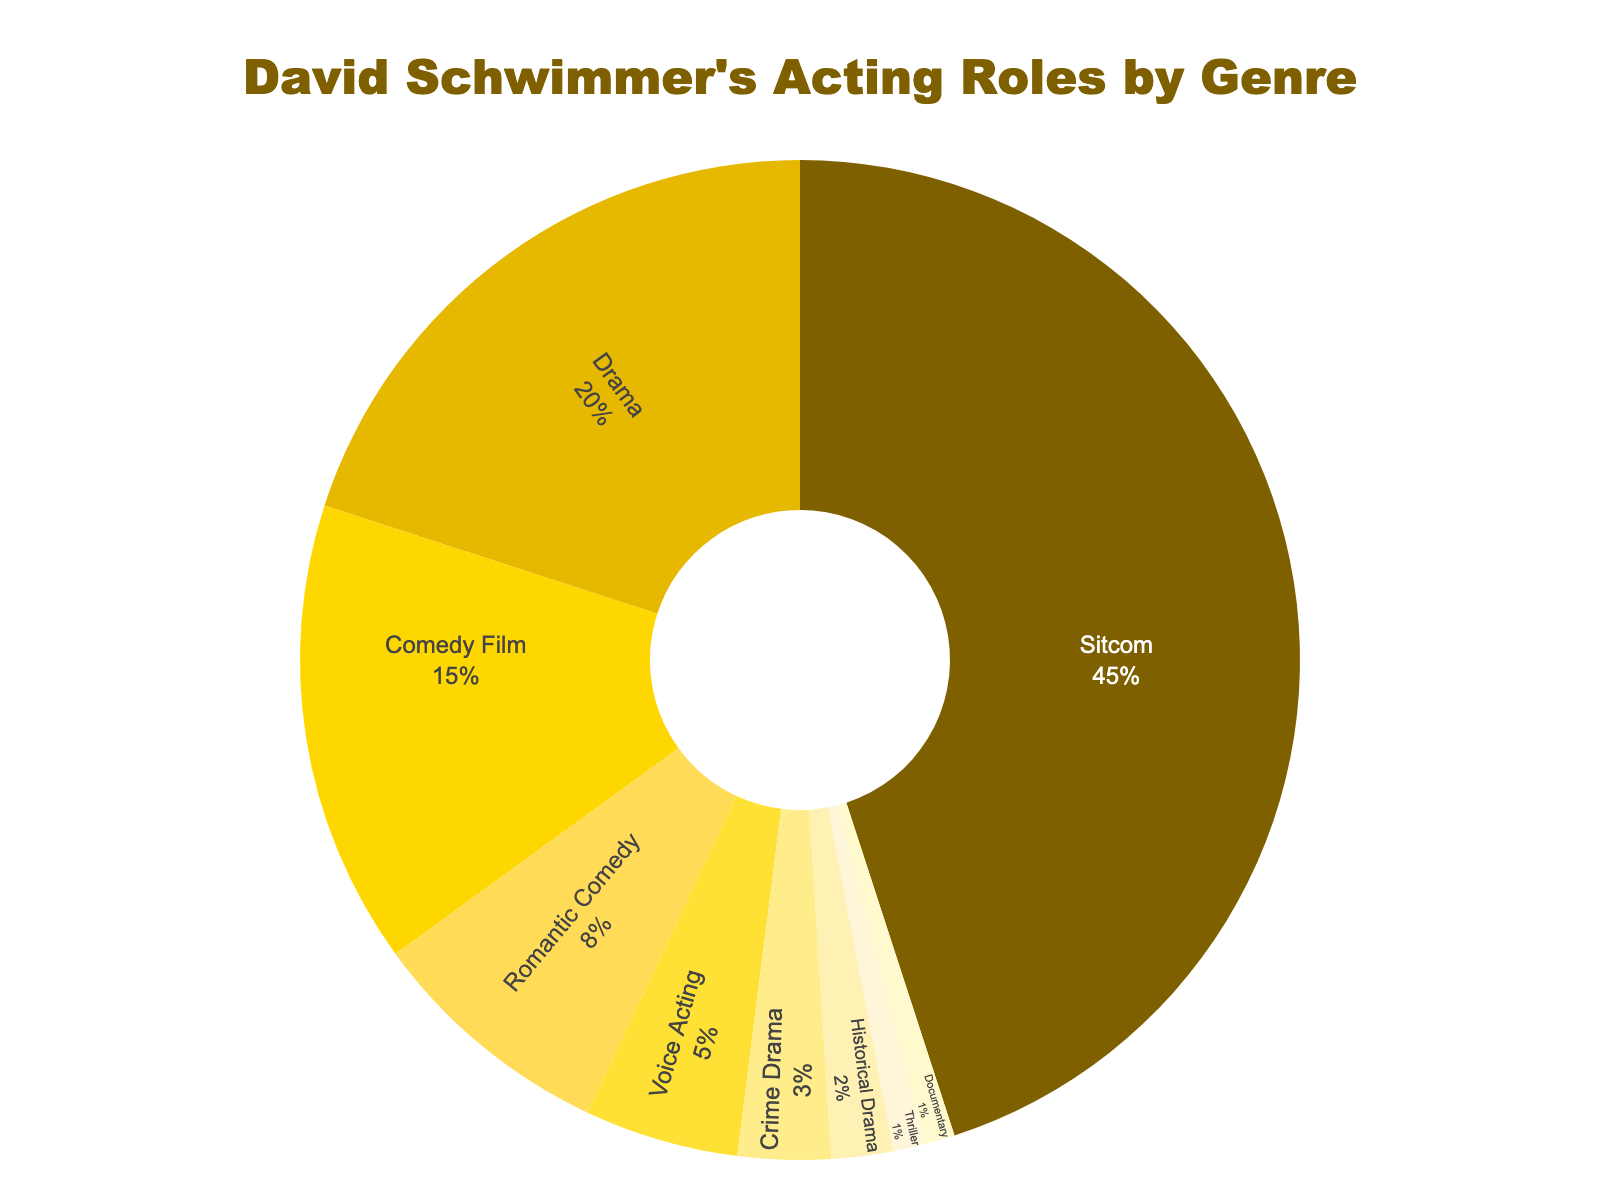What's the largest genre of David Schwimmer's acting roles? The pie chart shows that the genre with the largest percentage is Sitcom with 45%.
Answer: Sitcom What percentage of David Schwimmer's roles are in Sitcoms and Comedies combined? Add the percentages of Sitcom (45%) and Comedy Film (15%). The total is 45% + 15% = 60%.
Answer: 60% Which genre has a smaller percentage of acting roles, Romantic Comedy or Voice Acting? The pie chart shows Voice Acting accounts for 5% and Romantic Comedy accounts for 8%. 5% is smaller than 8%.
Answer: Voice Acting How much more percentage does Drama occupy compared to Crime Drama? Subtract the percentage of Crime Drama (3%) from the percentage of Drama (20%). The difference is 20% - 3% = 17%.
Answer: 17% Is the percentage of Historical Drama roles equal to or less than the percentage of Thriller roles? The pie chart shows Historical Drama at 2% and Thriller at 1%. 2% is greater than 1%, so Historical Drama is not equal to or less.
Answer: No What is the combined percentage of the three least represented genres? The three least represented genres are Historical Drama (2%), Thriller (1%), and Documentary (1%). Summing these gives 2% + 1% + 1% = 4%.
Answer: 4% Which genre has the second highest representation in David Schwimmer's acting roles? The pie chart shows the second highest percentage is Drama with 20% after Sitcom with 45%.
Answer: Drama What percentage of David Schwimmer's acting roles are not in sitcoms? To find this, subtract the Sitcom percentage (45%) from the total (100%). The result is 100% - 45% = 55%.
Answer: 55% How many genres have a smaller percentage than Romantic Comedy? The pie chart shows Romantic Comedy is at 8%. The genres with smaller percentages are Voice Acting (5%), Crime Drama (3%), Historical Drama (2%), Thriller (1%), and Documentary (1%) - totaling 5 genres.
Answer: 5 Comparing Drama and Comedy Film roles, what is the ratio of their percentages? Percentages for Drama is 20% and for Comedy Film is 15%. The ratio is 20:15, which simplifies to 4:3.
Answer: 4:3 